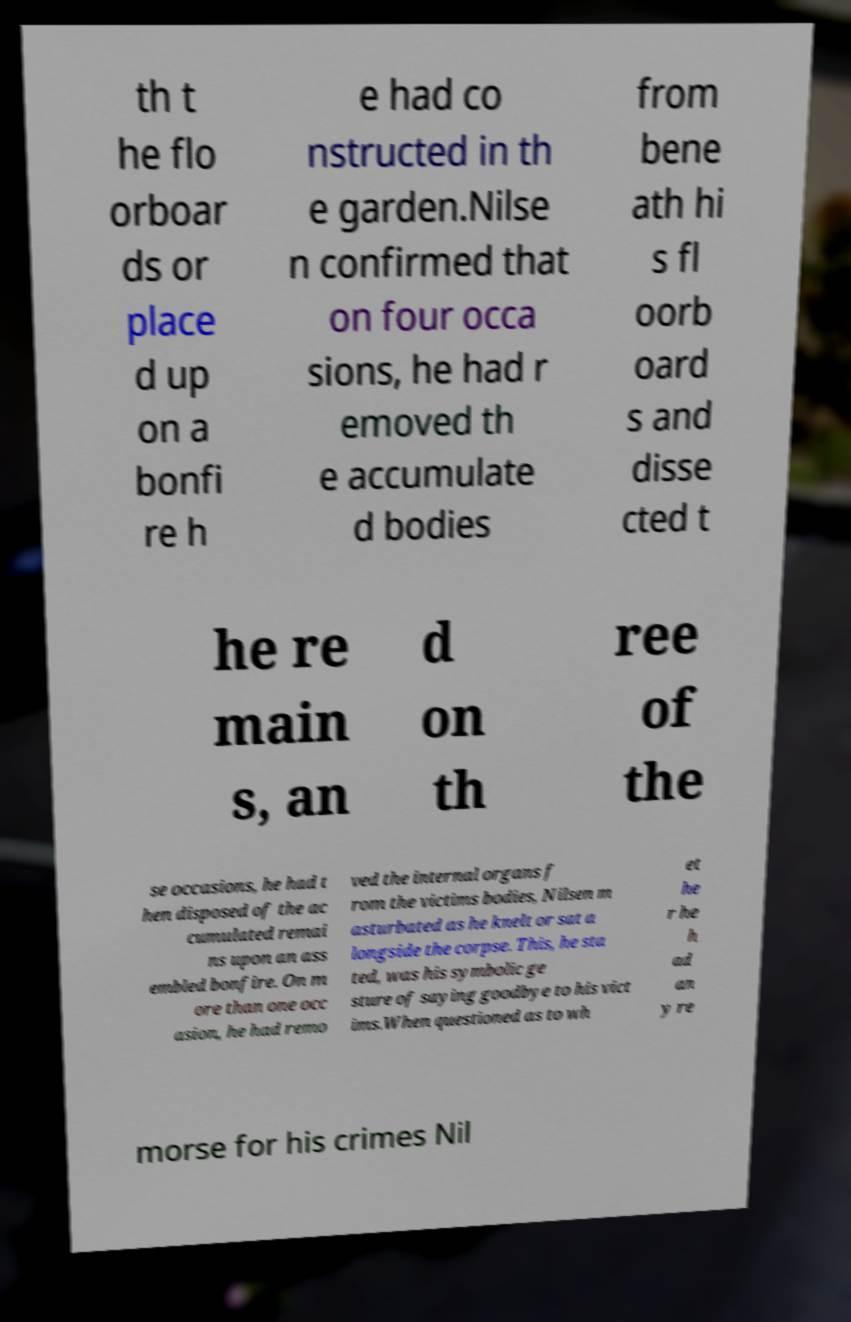Please identify and transcribe the text found in this image. th t he flo orboar ds or place d up on a bonfi re h e had co nstructed in th e garden.Nilse n confirmed that on four occa sions, he had r emoved th e accumulate d bodies from bene ath hi s fl oorb oard s and disse cted t he re main s, an d on th ree of the se occasions, he had t hen disposed of the ac cumulated remai ns upon an ass embled bonfire. On m ore than one occ asion, he had remo ved the internal organs f rom the victims bodies, Nilsen m asturbated as he knelt or sat a longside the corpse. This, he sta ted, was his symbolic ge sture of saying goodbye to his vict ims.When questioned as to wh et he r he h ad an y re morse for his crimes Nil 